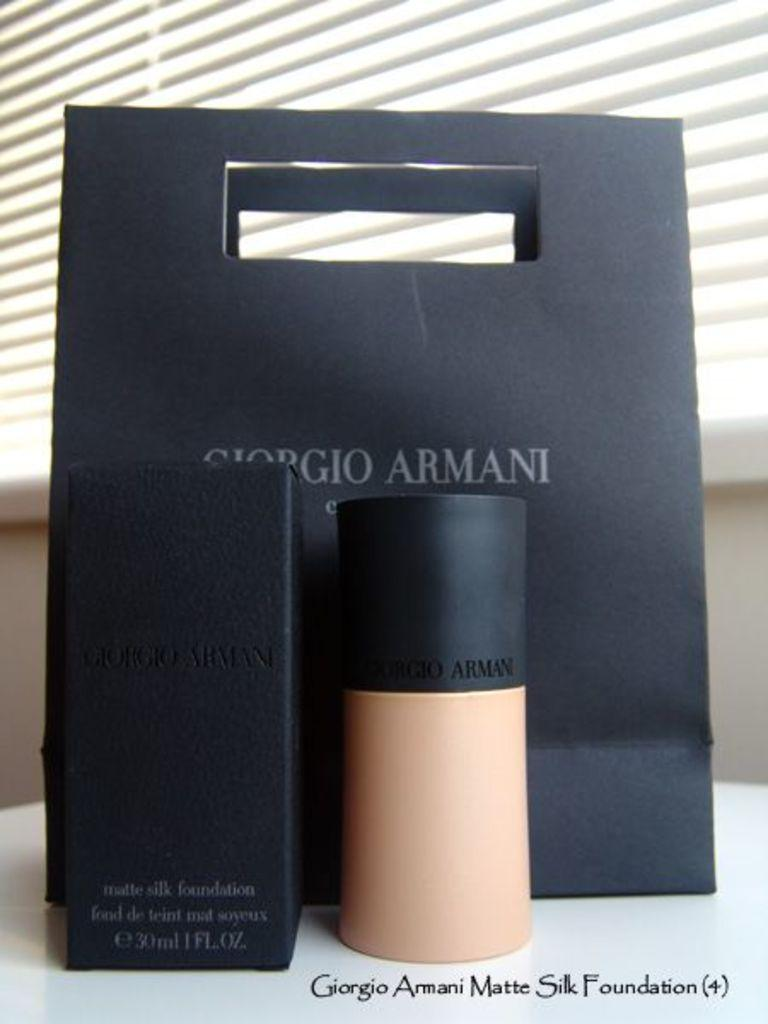<image>
Describe the image concisely. Giorgio Armani make up and the packaging boxes it comes in. 